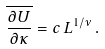Convert formula to latex. <formula><loc_0><loc_0><loc_500><loc_500>\overline { \frac { \partial U } { \partial \kappa } } = c \, L ^ { 1 / \nu } \, .</formula> 